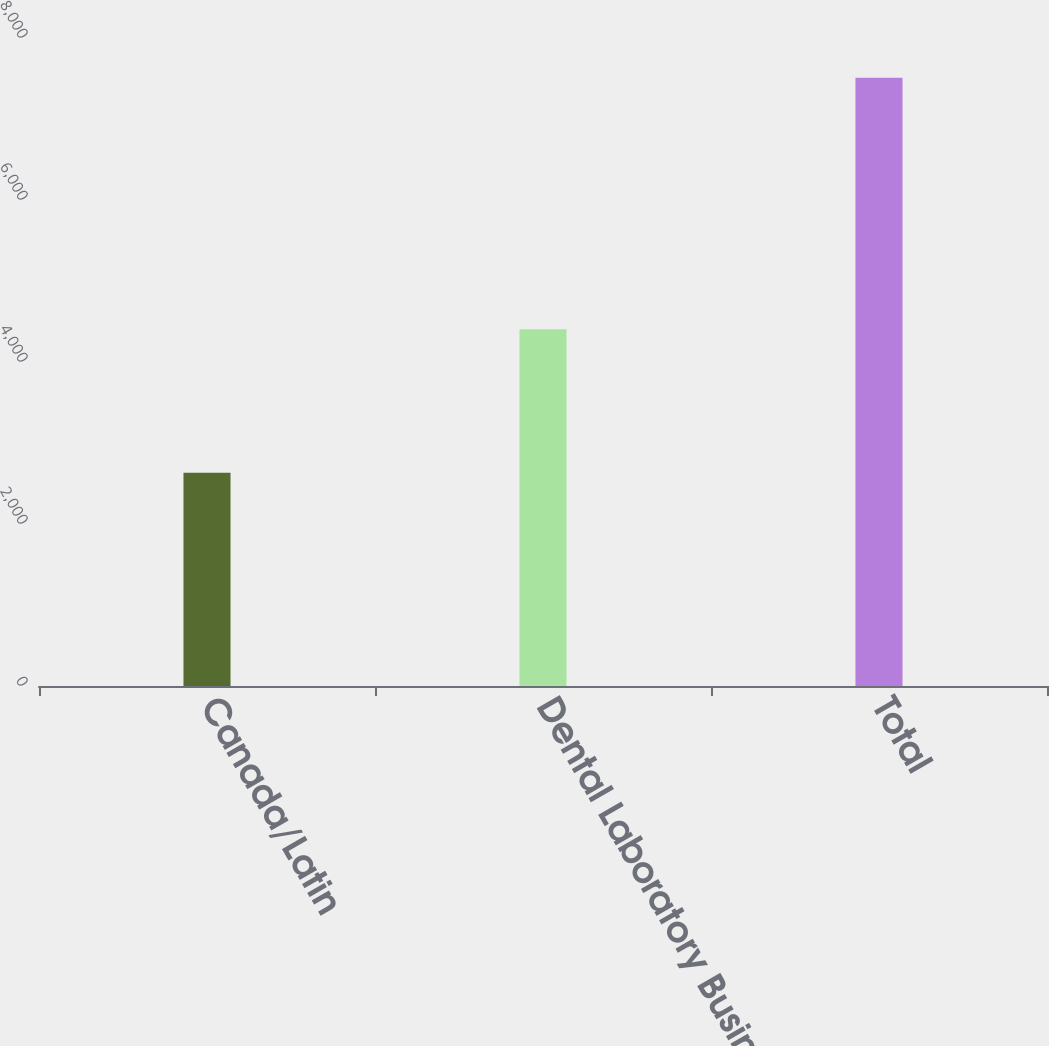Convert chart to OTSL. <chart><loc_0><loc_0><loc_500><loc_500><bar_chart><fcel>Canada/Latin<fcel>Dental Laboratory Business/<fcel>Total<nl><fcel>2633<fcel>4404<fcel>7509<nl></chart> 